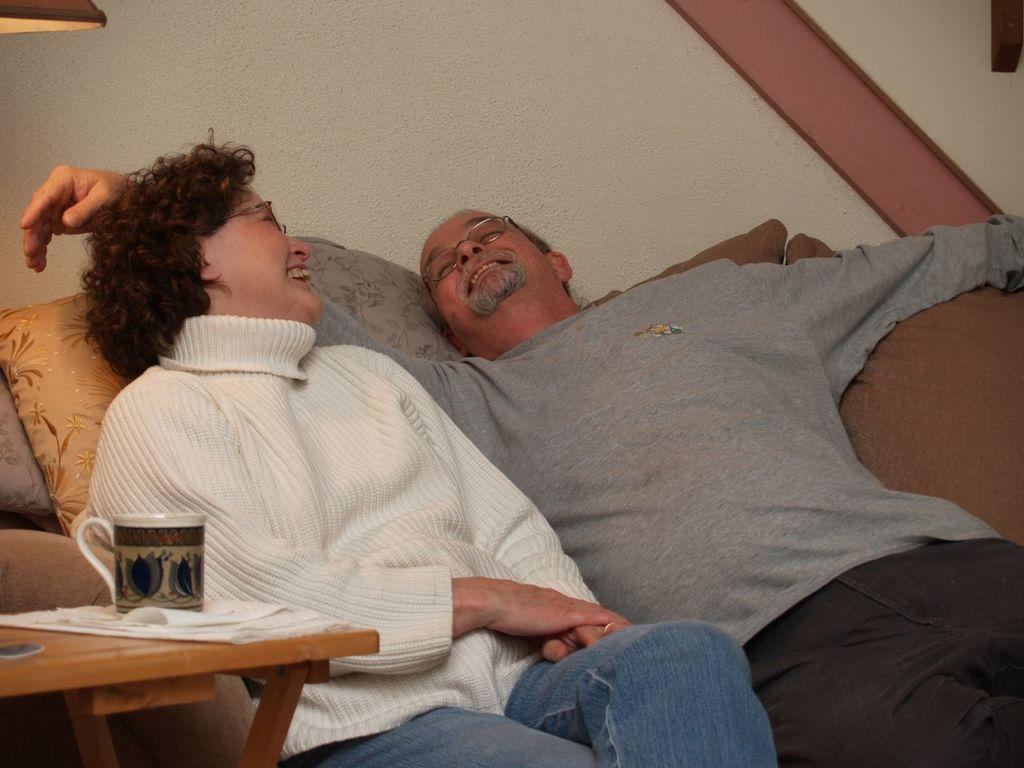How many people are in the image? There are two persons in the image. What are the persons doing in the image? The persons are sitting on a sofa. What is located beside the sofa? There is a table beside the sofa. What can be seen on the table? There is a mug on the table. What is the weight of the reward given to the person on the left in the image? There is no reward present in the image, and therefore no weight can be determined. 